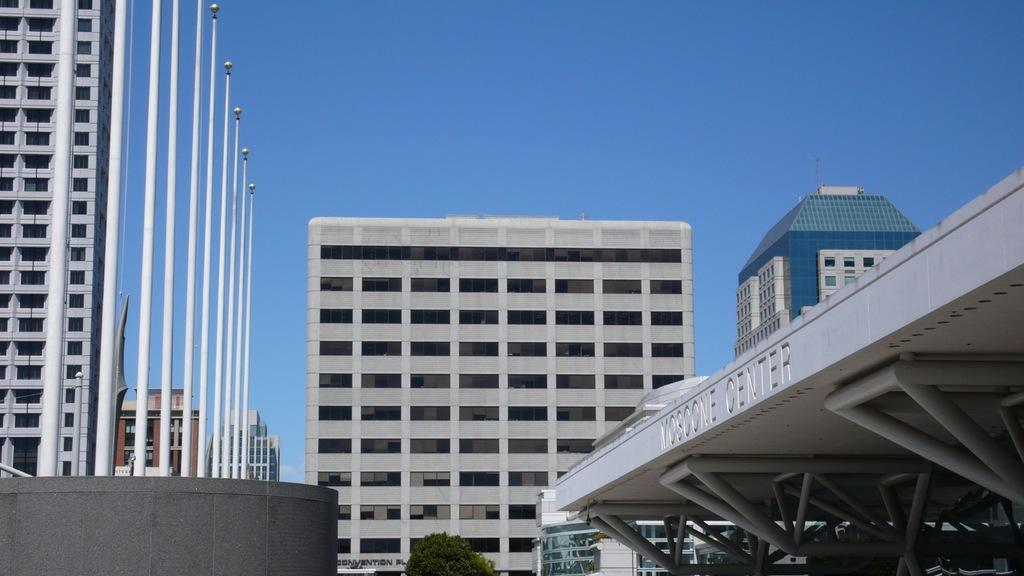What is the main subject in the center of the image? There is a tree in the center of the image. What can be seen on the left side of the image? There are white poles on the left side of the image. What type of structures are visible in the image? There are many buildings in the image. What is visible at the top of the image? The sky is visible at the top of the image. What is the price of the tree in the image? The image does not provide information about the price of the tree, as it is not a product for sale. 